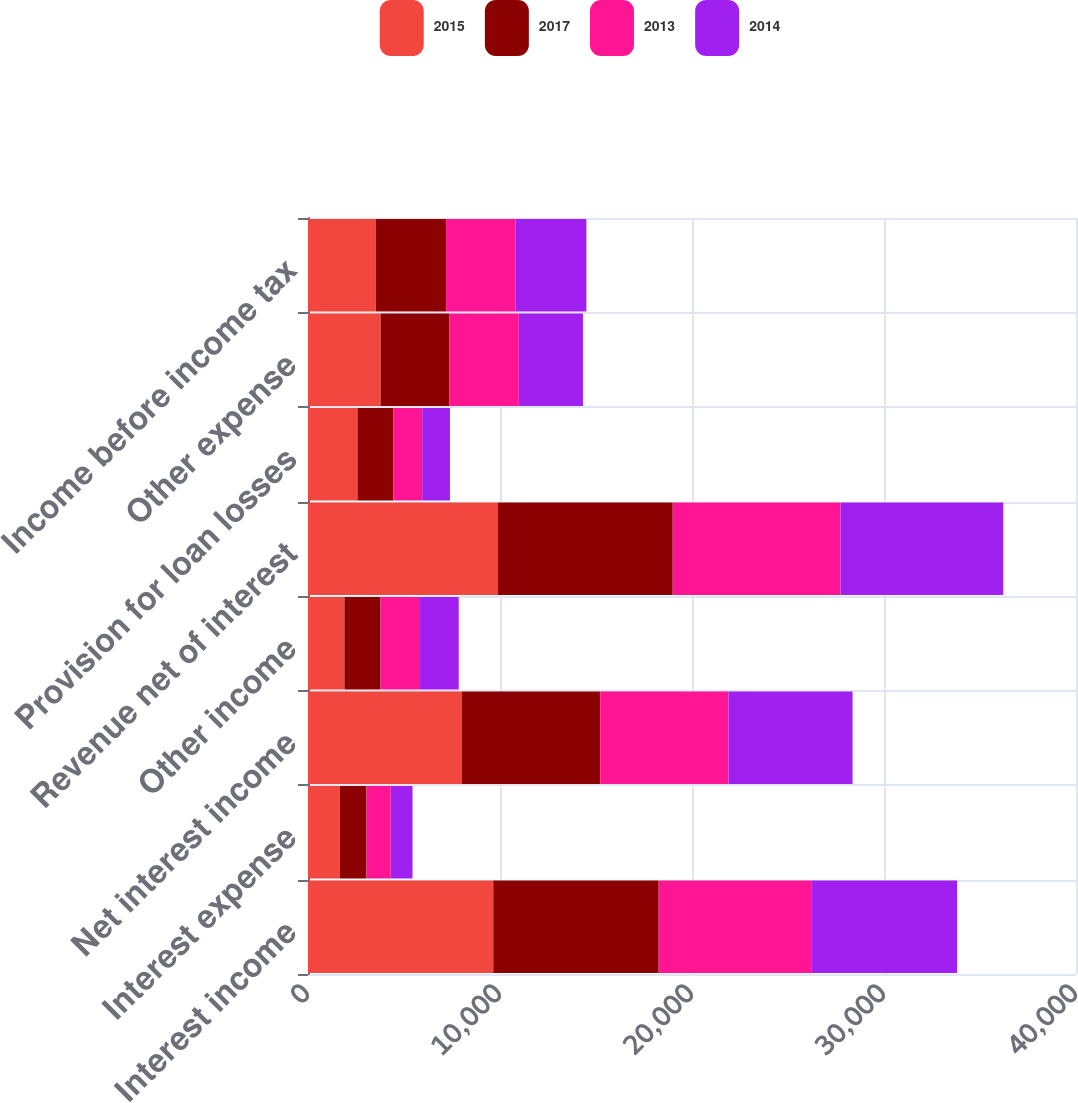<chart> <loc_0><loc_0><loc_500><loc_500><stacked_bar_chart><ecel><fcel>Interest income<fcel>Interest expense<fcel>Net interest income<fcel>Other income<fcel>Revenue net of interest<fcel>Provision for loan losses<fcel>Other expense<fcel>Income before income tax<nl><fcel>2015<fcel>9648<fcel>1648<fcel>8000<fcel>1897<fcel>9897<fcel>2579<fcel>3781<fcel>3537<nl><fcel>2017<fcel>8616<fcel>1398<fcel>7218<fcel>1881<fcel>9099<fcel>1859<fcel>3584<fcel>3656<nl><fcel>2013<fcel>7945<fcel>1263<fcel>6682<fcel>2057<fcel>8739<fcel>1512<fcel>3615<fcel>3612<nl><fcel>2014<fcel>7596<fcel>1134<fcel>6462<fcel>2015<fcel>8477<fcel>1443<fcel>3340<fcel>3694<nl></chart> 